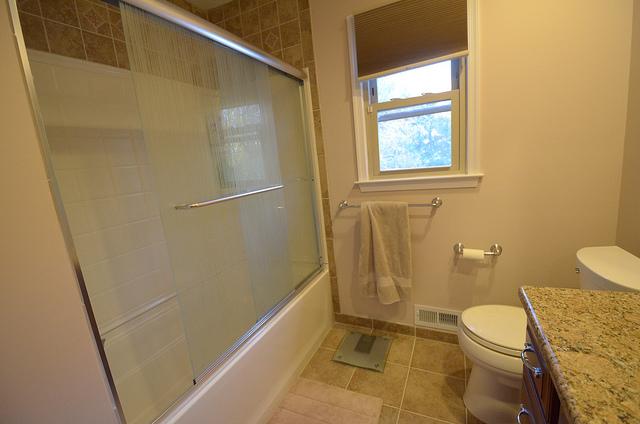How many towels in this photo?
Keep it brief. 1. Is there a full roll of toilet paper present?
Be succinct. No. Where is the towel?
Be succinct. On towel rack. Are the shower walls translucent or transparent?
Be succinct. Translucent. What are the shower doors made of?
Give a very brief answer. Glass. Does someone injured live here?
Be succinct. No. 